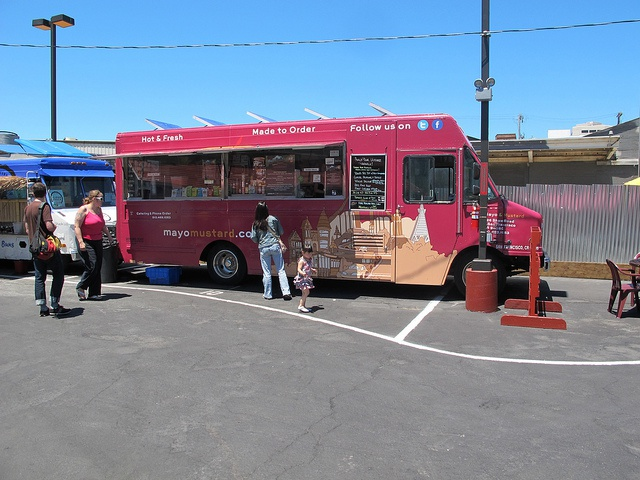Describe the objects in this image and their specific colors. I can see truck in lightblue, black, maroon, gray, and brown tones, bus in lightblue, black, maroon, gray, and brown tones, truck in lightblue, black, gray, and lightgray tones, bus in lightblue, black, gray, lightgray, and navy tones, and people in lightblue, black, gray, and maroon tones in this image. 